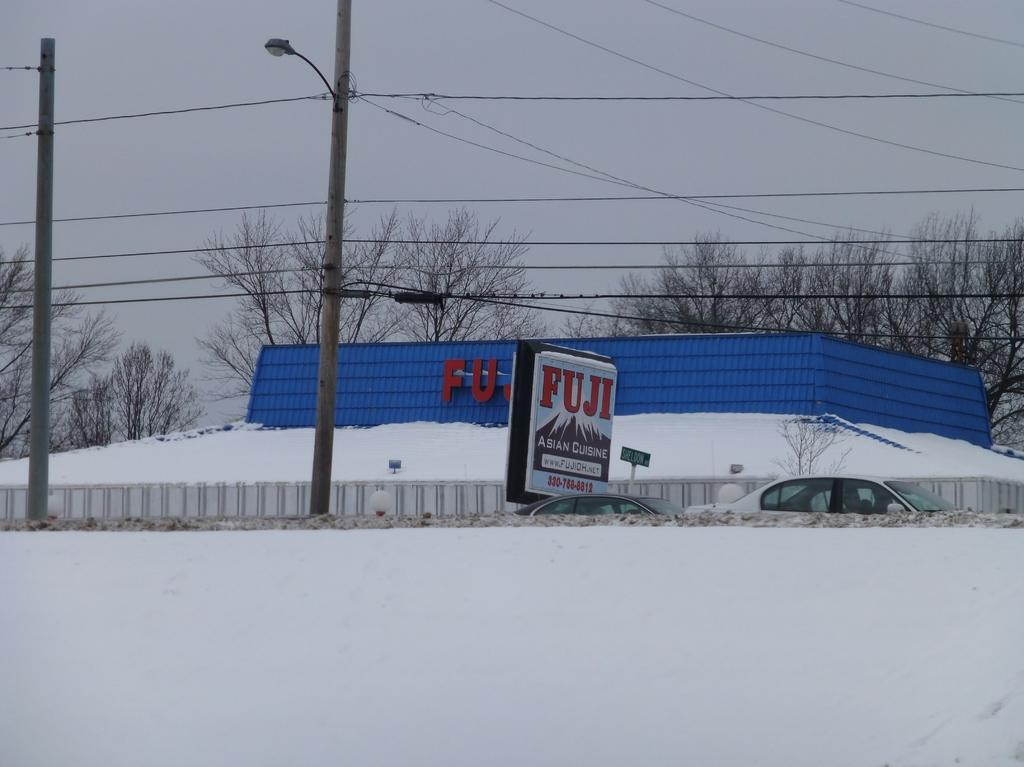Provide a one-sentence caption for the provided image. FUJI store covered in snow on a cloudy day. 